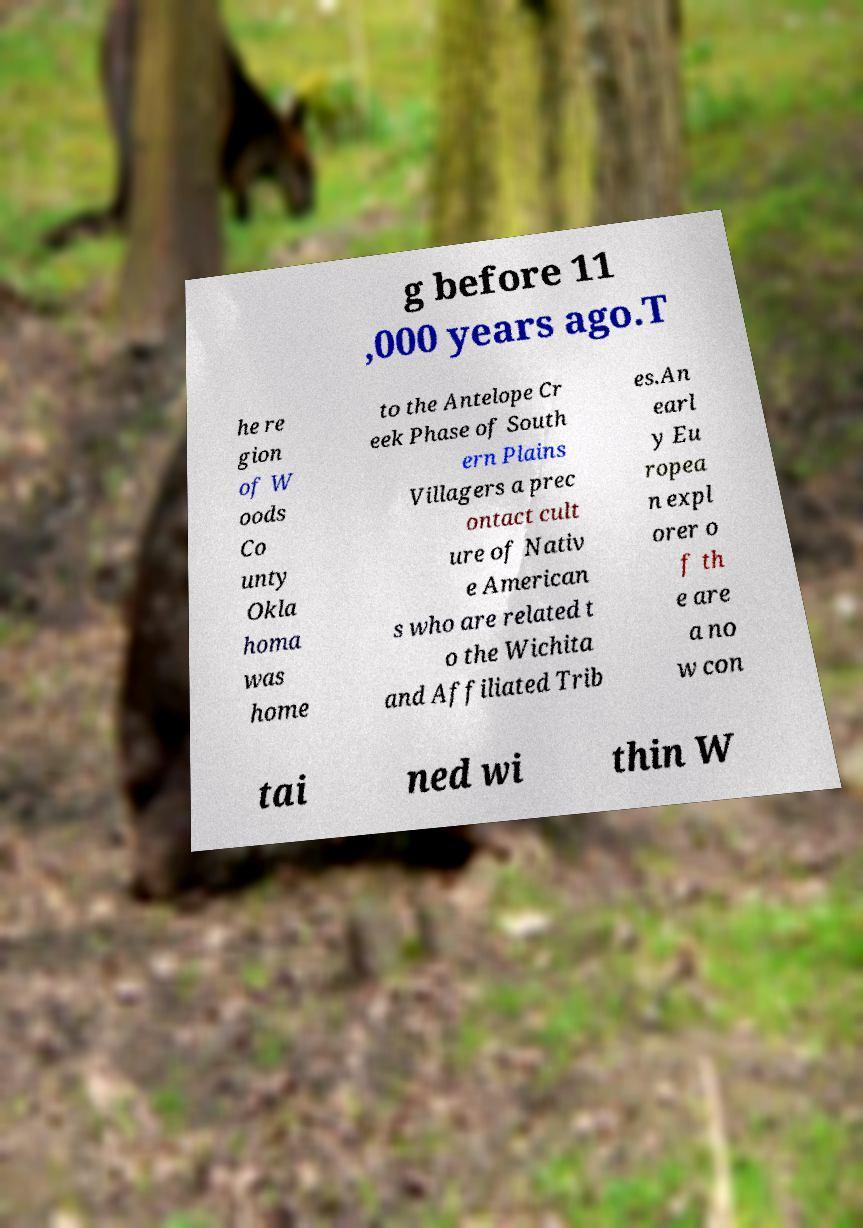I need the written content from this picture converted into text. Can you do that? g before 11 ,000 years ago.T he re gion of W oods Co unty Okla homa was home to the Antelope Cr eek Phase of South ern Plains Villagers a prec ontact cult ure of Nativ e American s who are related t o the Wichita and Affiliated Trib es.An earl y Eu ropea n expl orer o f th e are a no w con tai ned wi thin W 